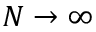Convert formula to latex. <formula><loc_0><loc_0><loc_500><loc_500>N \rightarrow \infty</formula> 